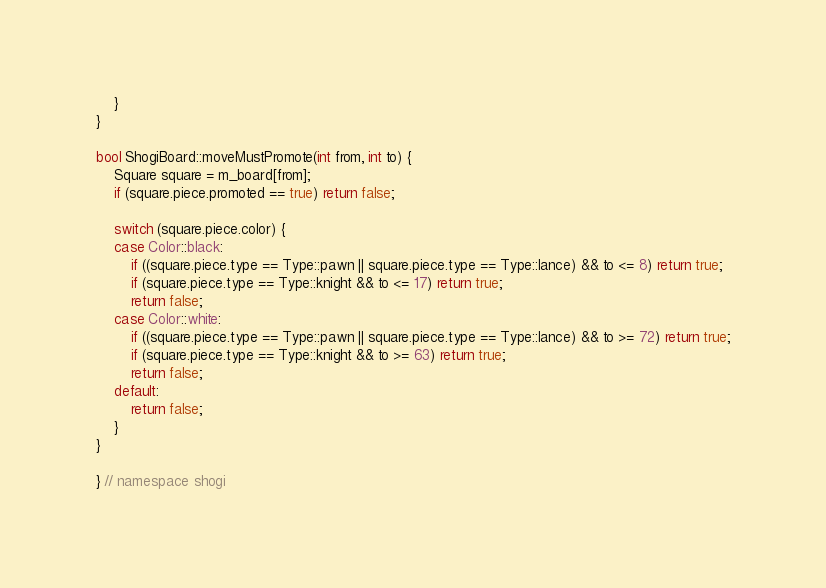Convert code to text. <code><loc_0><loc_0><loc_500><loc_500><_C++_>    }
}

bool ShogiBoard::moveMustPromote(int from, int to) {
    Square square = m_board[from];
    if (square.piece.promoted == true) return false;

    switch (square.piece.color) {
    case Color::black:
        if ((square.piece.type == Type::pawn || square.piece.type == Type::lance) && to <= 8) return true;
        if (square.piece.type == Type::knight && to <= 17) return true;
        return false;
    case Color::white:
        if ((square.piece.type == Type::pawn || square.piece.type == Type::lance) && to >= 72) return true;
        if (square.piece.type == Type::knight && to >= 63) return true;
        return false;
    default:
        return false;
    }
}

} // namespace shogi
</code> 